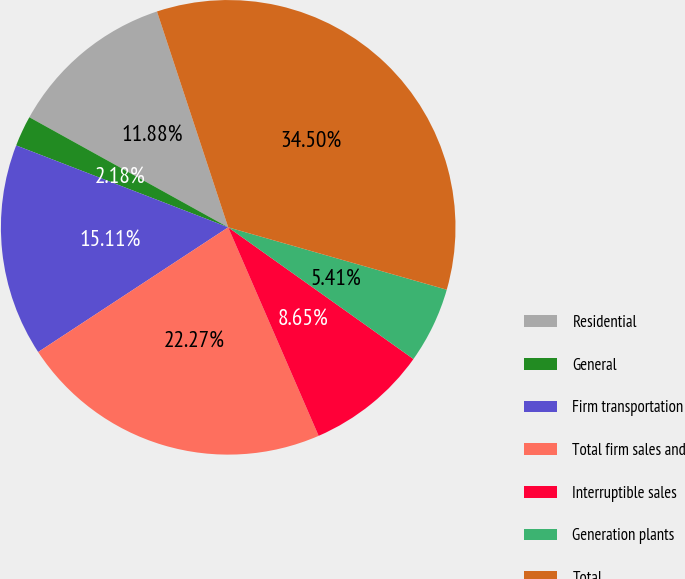Convert chart. <chart><loc_0><loc_0><loc_500><loc_500><pie_chart><fcel>Residential<fcel>General<fcel>Firm transportation<fcel>Total firm sales and<fcel>Interruptible sales<fcel>Generation plants<fcel>Total<nl><fcel>11.88%<fcel>2.18%<fcel>15.11%<fcel>22.27%<fcel>8.65%<fcel>5.41%<fcel>34.5%<nl></chart> 